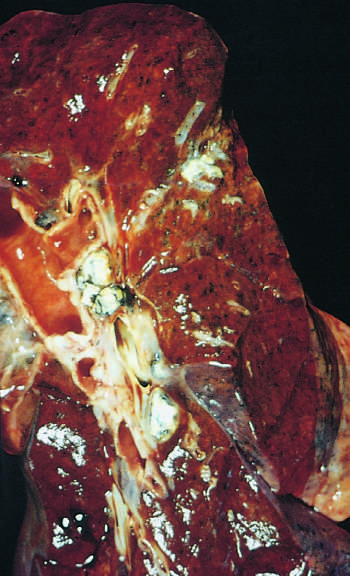s the gray-white parenchymal focus under the pleura in the lower part of the upper lobe?
Answer the question using a single word or phrase. Yes 